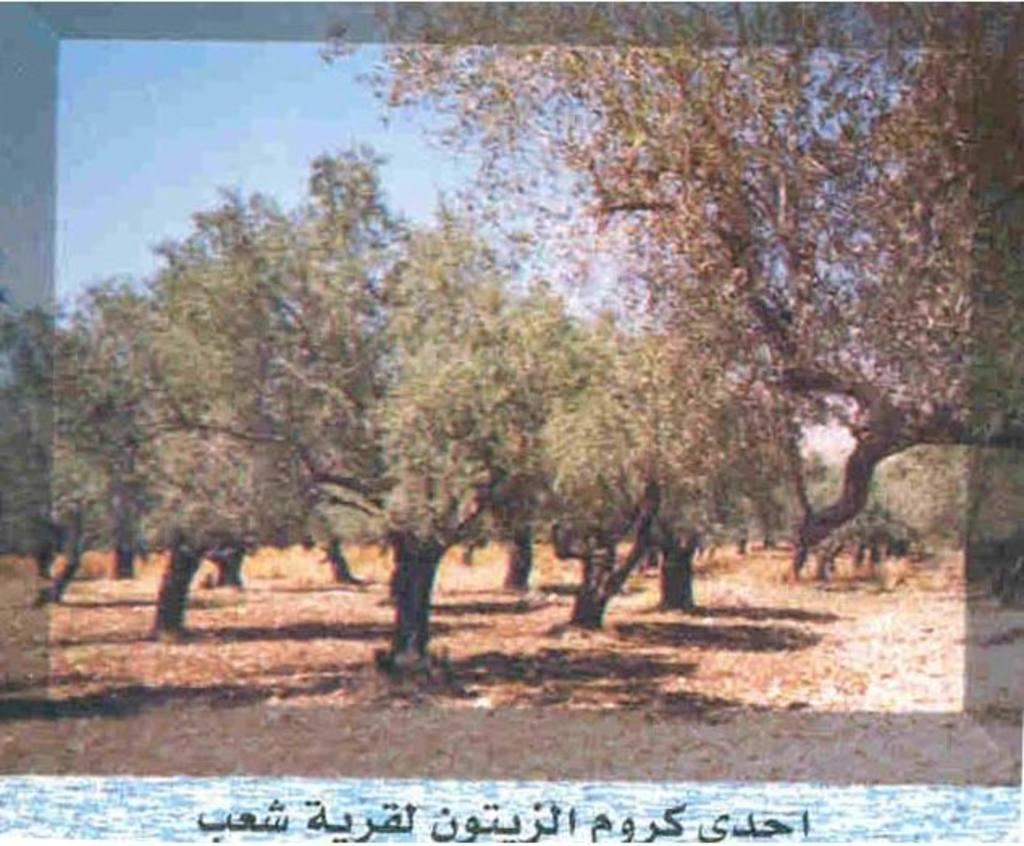What type of natural elements can be seen in the image? There are trees in the image. What part of the sky is visible in the image? The sky is visible in the top left of the image. What type of information is present at the bottom of the image? There is text at the bottom of the image. What type of fuel is being used by the fan in the image? There is no fan present in the image, so it is not possible to determine what type of fuel it might use. 